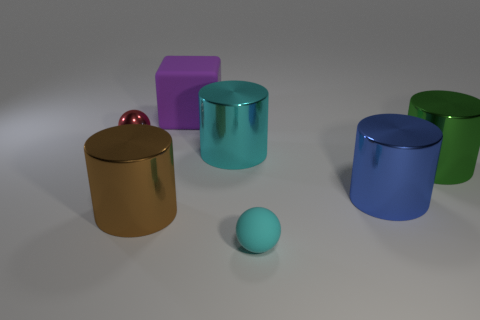There is a large metallic thing that is the same color as the rubber sphere; what is its shape?
Offer a terse response. Cylinder. What size is the shiny object that is the same color as the small matte thing?
Give a very brief answer. Large. What number of small cyan matte objects have the same shape as the tiny red metallic thing?
Make the answer very short. 1. The cyan object that is the same size as the rubber block is what shape?
Your answer should be very brief. Cylinder. There is a red ball; are there any big green things in front of it?
Provide a short and direct response. Yes. Is there a big brown thing to the right of the ball behind the cyan ball?
Your answer should be compact. Yes. Are there fewer purple matte cubes behind the green metallic cylinder than things right of the small red object?
Your response must be concise. Yes. Are there any other things that have the same size as the purple rubber cube?
Make the answer very short. Yes. The large purple object has what shape?
Provide a short and direct response. Cube. There is a small thing on the right side of the tiny shiny sphere; what material is it?
Your response must be concise. Rubber. 